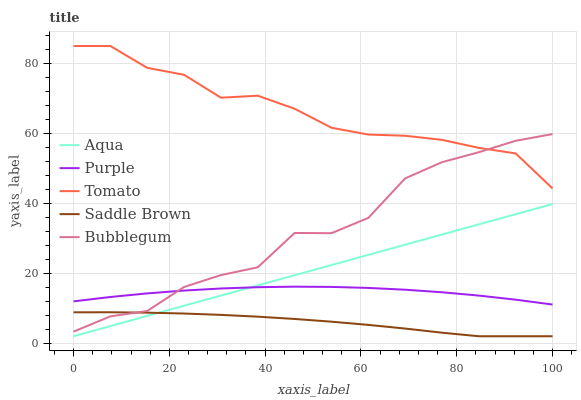Does Saddle Brown have the minimum area under the curve?
Answer yes or no. Yes. Does Tomato have the maximum area under the curve?
Answer yes or no. Yes. Does Aqua have the minimum area under the curve?
Answer yes or no. No. Does Aqua have the maximum area under the curve?
Answer yes or no. No. Is Aqua the smoothest?
Answer yes or no. Yes. Is Bubblegum the roughest?
Answer yes or no. Yes. Is Tomato the smoothest?
Answer yes or no. No. Is Tomato the roughest?
Answer yes or no. No. Does Aqua have the lowest value?
Answer yes or no. Yes. Does Tomato have the lowest value?
Answer yes or no. No. Does Tomato have the highest value?
Answer yes or no. Yes. Does Aqua have the highest value?
Answer yes or no. No. Is Saddle Brown less than Purple?
Answer yes or no. Yes. Is Bubblegum greater than Aqua?
Answer yes or no. Yes. Does Bubblegum intersect Purple?
Answer yes or no. Yes. Is Bubblegum less than Purple?
Answer yes or no. No. Is Bubblegum greater than Purple?
Answer yes or no. No. Does Saddle Brown intersect Purple?
Answer yes or no. No. 